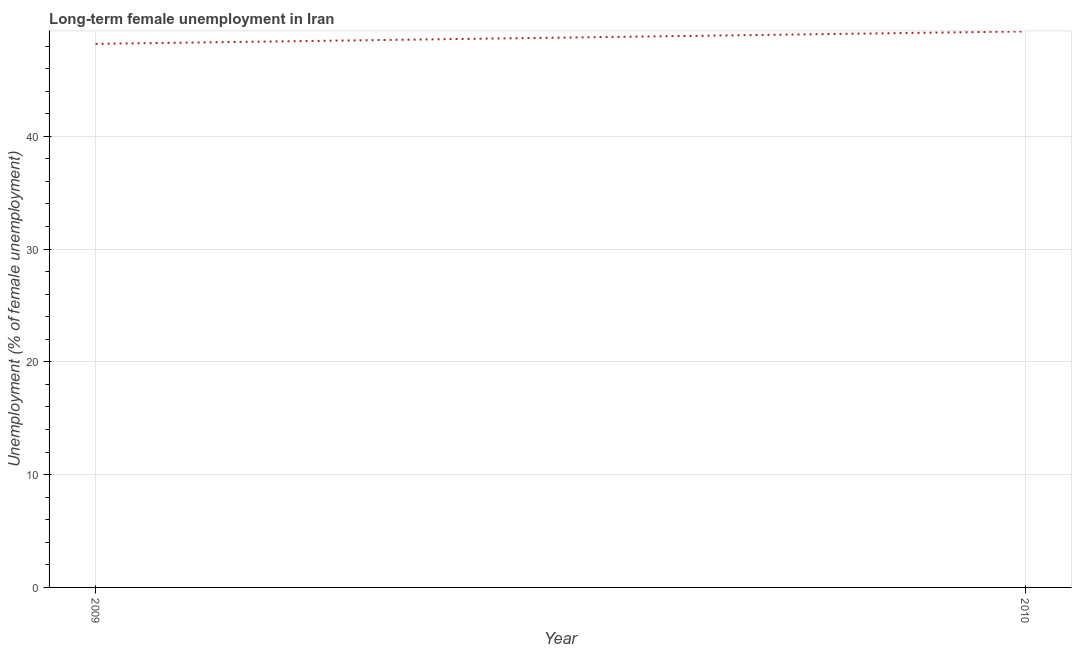What is the long-term female unemployment in 2010?
Offer a terse response. 49.3. Across all years, what is the maximum long-term female unemployment?
Offer a terse response. 49.3. Across all years, what is the minimum long-term female unemployment?
Give a very brief answer. 48.2. What is the sum of the long-term female unemployment?
Offer a terse response. 97.5. What is the difference between the long-term female unemployment in 2009 and 2010?
Keep it short and to the point. -1.1. What is the average long-term female unemployment per year?
Keep it short and to the point. 48.75. What is the median long-term female unemployment?
Give a very brief answer. 48.75. In how many years, is the long-term female unemployment greater than 14 %?
Keep it short and to the point. 2. Do a majority of the years between 2009 and 2010 (inclusive) have long-term female unemployment greater than 24 %?
Keep it short and to the point. Yes. What is the ratio of the long-term female unemployment in 2009 to that in 2010?
Your response must be concise. 0.98. Is the long-term female unemployment in 2009 less than that in 2010?
Offer a very short reply. Yes. How many years are there in the graph?
Make the answer very short. 2. What is the difference between two consecutive major ticks on the Y-axis?
Ensure brevity in your answer.  10. Are the values on the major ticks of Y-axis written in scientific E-notation?
Provide a succinct answer. No. Does the graph contain grids?
Your response must be concise. Yes. What is the title of the graph?
Give a very brief answer. Long-term female unemployment in Iran. What is the label or title of the X-axis?
Provide a short and direct response. Year. What is the label or title of the Y-axis?
Ensure brevity in your answer.  Unemployment (% of female unemployment). What is the Unemployment (% of female unemployment) in 2009?
Keep it short and to the point. 48.2. What is the Unemployment (% of female unemployment) of 2010?
Keep it short and to the point. 49.3. What is the ratio of the Unemployment (% of female unemployment) in 2009 to that in 2010?
Offer a terse response. 0.98. 